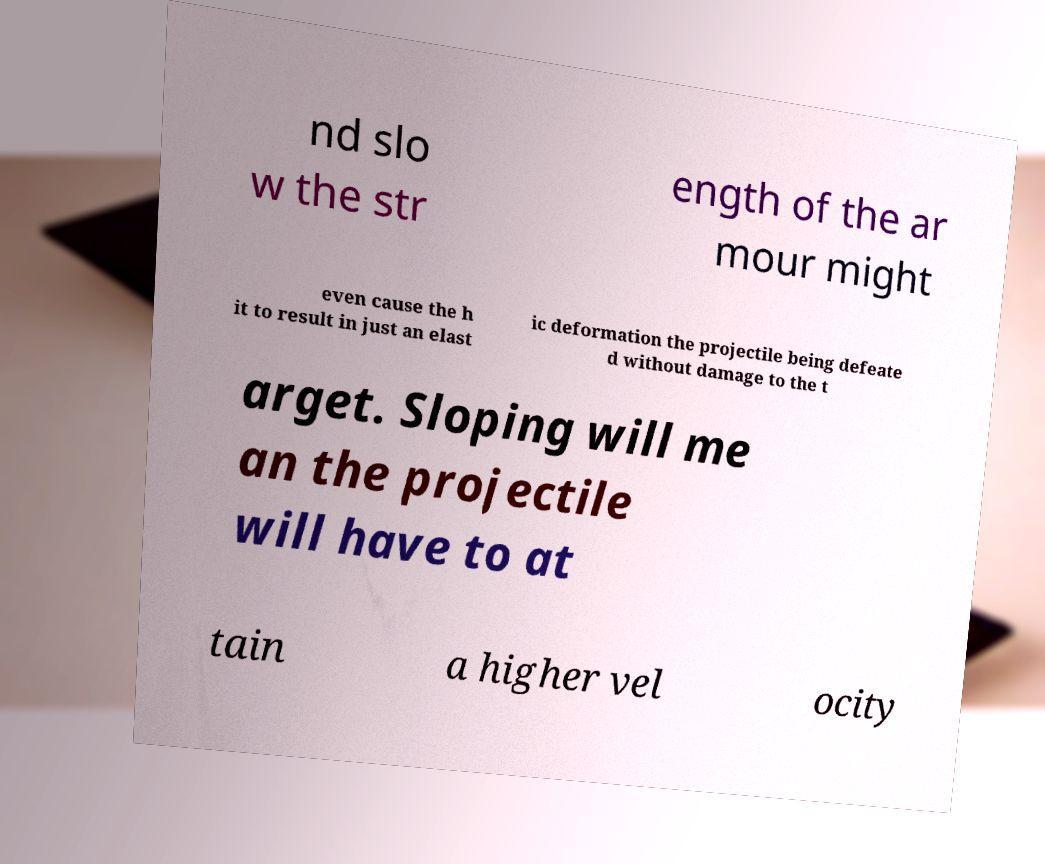Can you accurately transcribe the text from the provided image for me? nd slo w the str ength of the ar mour might even cause the h it to result in just an elast ic deformation the projectile being defeate d without damage to the t arget. Sloping will me an the projectile will have to at tain a higher vel ocity 